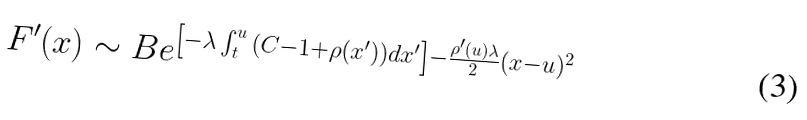<formula> <loc_0><loc_0><loc_500><loc_500>F ^ { \prime } ( x ) \sim B e ^ { \left [ - \lambda \int ^ { u } _ { t } { ( C - 1 + \rho ( x ^ { \prime } ) ) d x ^ { \prime } } \right ] - \frac { \rho ^ { \prime } ( u ) \lambda } { 2 } ( x - u ) ^ { 2 } }</formula> 